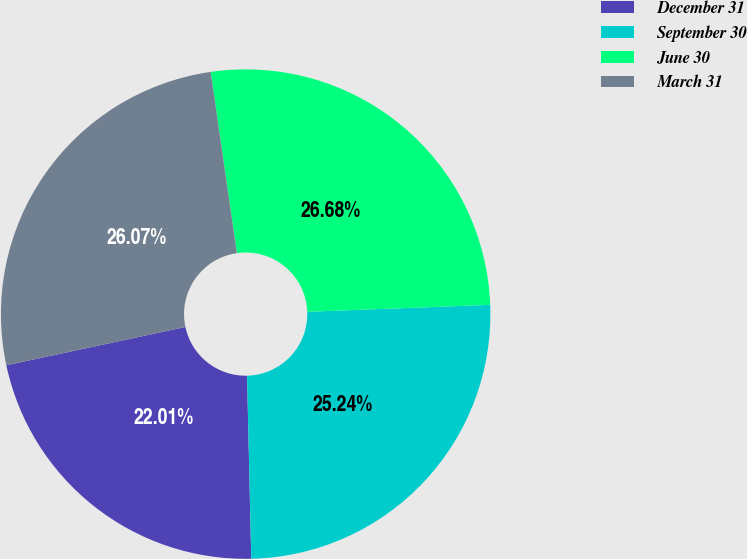Convert chart. <chart><loc_0><loc_0><loc_500><loc_500><pie_chart><fcel>December 31<fcel>September 30<fcel>June 30<fcel>March 31<nl><fcel>22.01%<fcel>25.24%<fcel>26.68%<fcel>26.07%<nl></chart> 